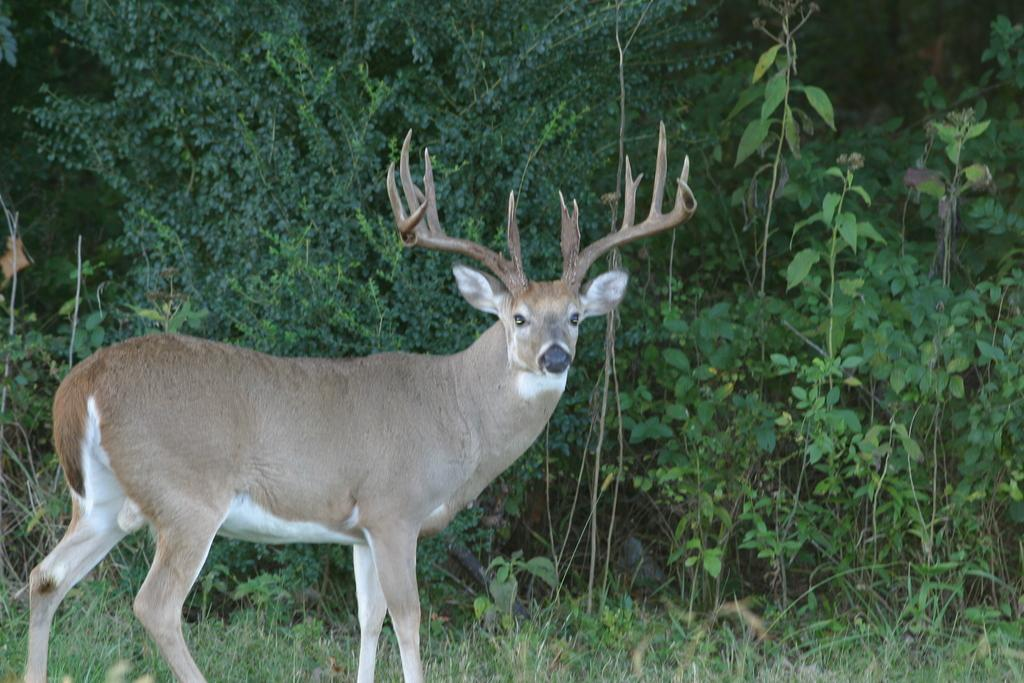What animal can be seen standing in the image? There is a deer standing in the image. What type of vegetation is at the bottom of the image? Grass is present at the bottom of the image. What can be seen in the background of the image? There are plants and trees in the background of the image. What type of wool is the deer wearing in the image? There is no wool present in the image, nor is the deer wearing any clothing. 